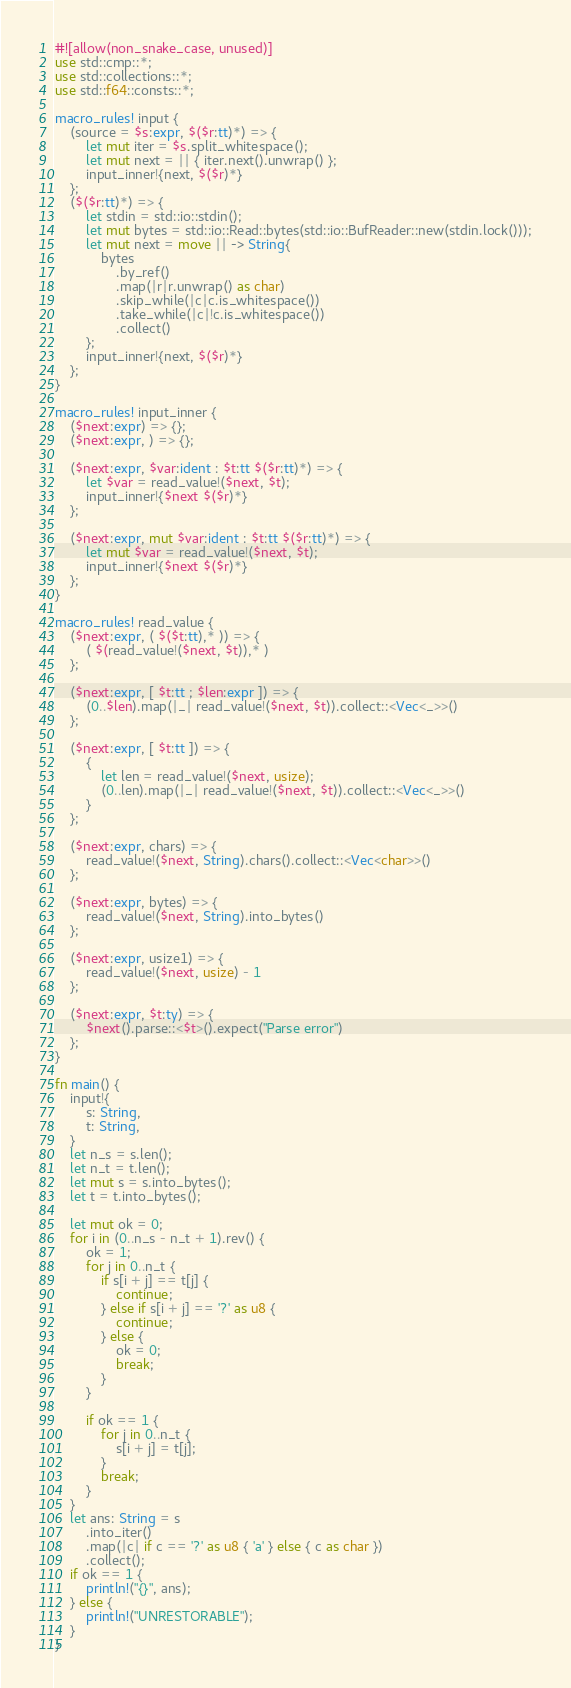<code> <loc_0><loc_0><loc_500><loc_500><_Rust_>#![allow(non_snake_case, unused)]
use std::cmp::*;
use std::collections::*;
use std::f64::consts::*;

macro_rules! input {
    (source = $s:expr, $($r:tt)*) => {
        let mut iter = $s.split_whitespace();
        let mut next = || { iter.next().unwrap() };
        input_inner!{next, $($r)*}
    };
    ($($r:tt)*) => {
        let stdin = std::io::stdin();
        let mut bytes = std::io::Read::bytes(std::io::BufReader::new(stdin.lock()));
        let mut next = move || -> String{
            bytes
                .by_ref()
                .map(|r|r.unwrap() as char)
                .skip_while(|c|c.is_whitespace())
                .take_while(|c|!c.is_whitespace())
                .collect()
        };
        input_inner!{next, $($r)*}
    };
}

macro_rules! input_inner {
    ($next:expr) => {};
    ($next:expr, ) => {};

    ($next:expr, $var:ident : $t:tt $($r:tt)*) => {
        let $var = read_value!($next, $t);
        input_inner!{$next $($r)*}
    };

    ($next:expr, mut $var:ident : $t:tt $($r:tt)*) => {
        let mut $var = read_value!($next, $t);
        input_inner!{$next $($r)*}
    };
}

macro_rules! read_value {
    ($next:expr, ( $($t:tt),* )) => {
        ( $(read_value!($next, $t)),* )
    };

    ($next:expr, [ $t:tt ; $len:expr ]) => {
        (0..$len).map(|_| read_value!($next, $t)).collect::<Vec<_>>()
    };

    ($next:expr, [ $t:tt ]) => {
        {
            let len = read_value!($next, usize);
            (0..len).map(|_| read_value!($next, $t)).collect::<Vec<_>>()
        }
    };

    ($next:expr, chars) => {
        read_value!($next, String).chars().collect::<Vec<char>>()
    };

    ($next:expr, bytes) => {
        read_value!($next, String).into_bytes()
    };

    ($next:expr, usize1) => {
        read_value!($next, usize) - 1
    };

    ($next:expr, $t:ty) => {
        $next().parse::<$t>().expect("Parse error")
    };
}

fn main() {
    input!{
        s: String,
        t: String,
    }
    let n_s = s.len();
    let n_t = t.len();
    let mut s = s.into_bytes();
    let t = t.into_bytes();

    let mut ok = 0;
    for i in (0..n_s - n_t + 1).rev() {
        ok = 1;
        for j in 0..n_t {
            if s[i + j] == t[j] {
                continue;
            } else if s[i + j] == '?' as u8 {
                continue;
            } else {
                ok = 0;
                break;
            }
        }

        if ok == 1 {
            for j in 0..n_t {
                s[i + j] = t[j];
            }
            break;
        }
    }
    let ans: String = s
        .into_iter()
        .map(|c| if c == '?' as u8 { 'a' } else { c as char })
        .collect();
    if ok == 1 {
        println!("{}", ans);
    } else {
        println!("UNRESTORABLE");
    }
}
</code> 